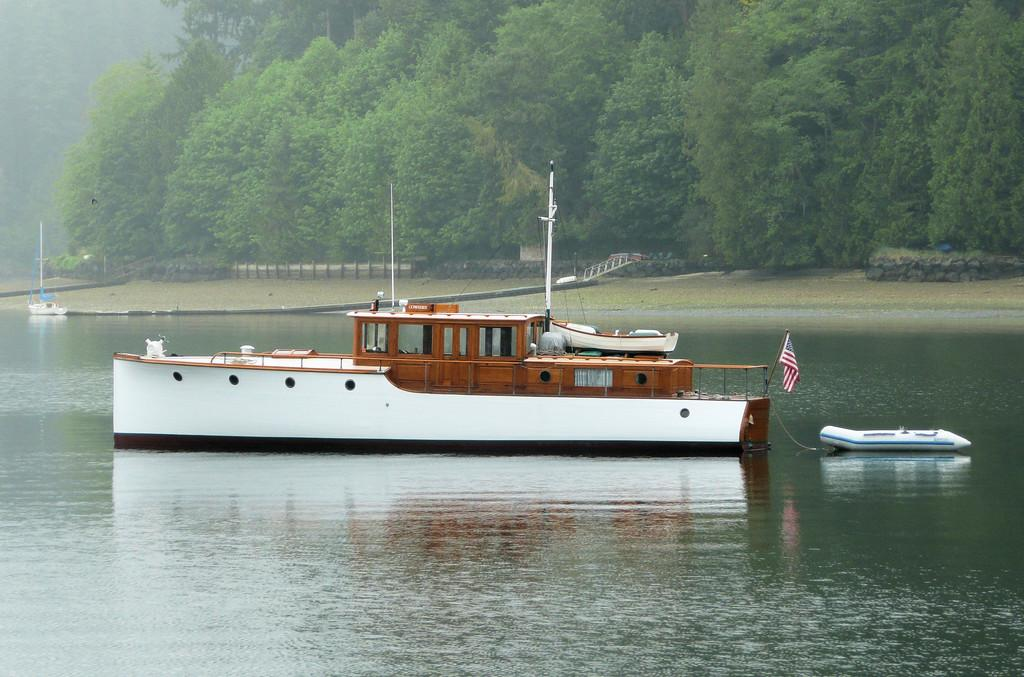What types of watercraft are visible in the image? There are ships and a boat in the image. Are the ships and boat in contact with the water? No, the ships and boat are above the water. What other objects can be seen in the image? There are poles and a flag in the image. What can be seen in the background of the image? There are trees, plants, a wall, grass, and a fence in the background of the image. What type of sleet can be seen falling from the sky in the image? There is no sleet present in the image; it is a clear day with ships, a boat, poles, and a flag. Can you tell me how many chickens are visible in the image? There are no chickens present in the image. 